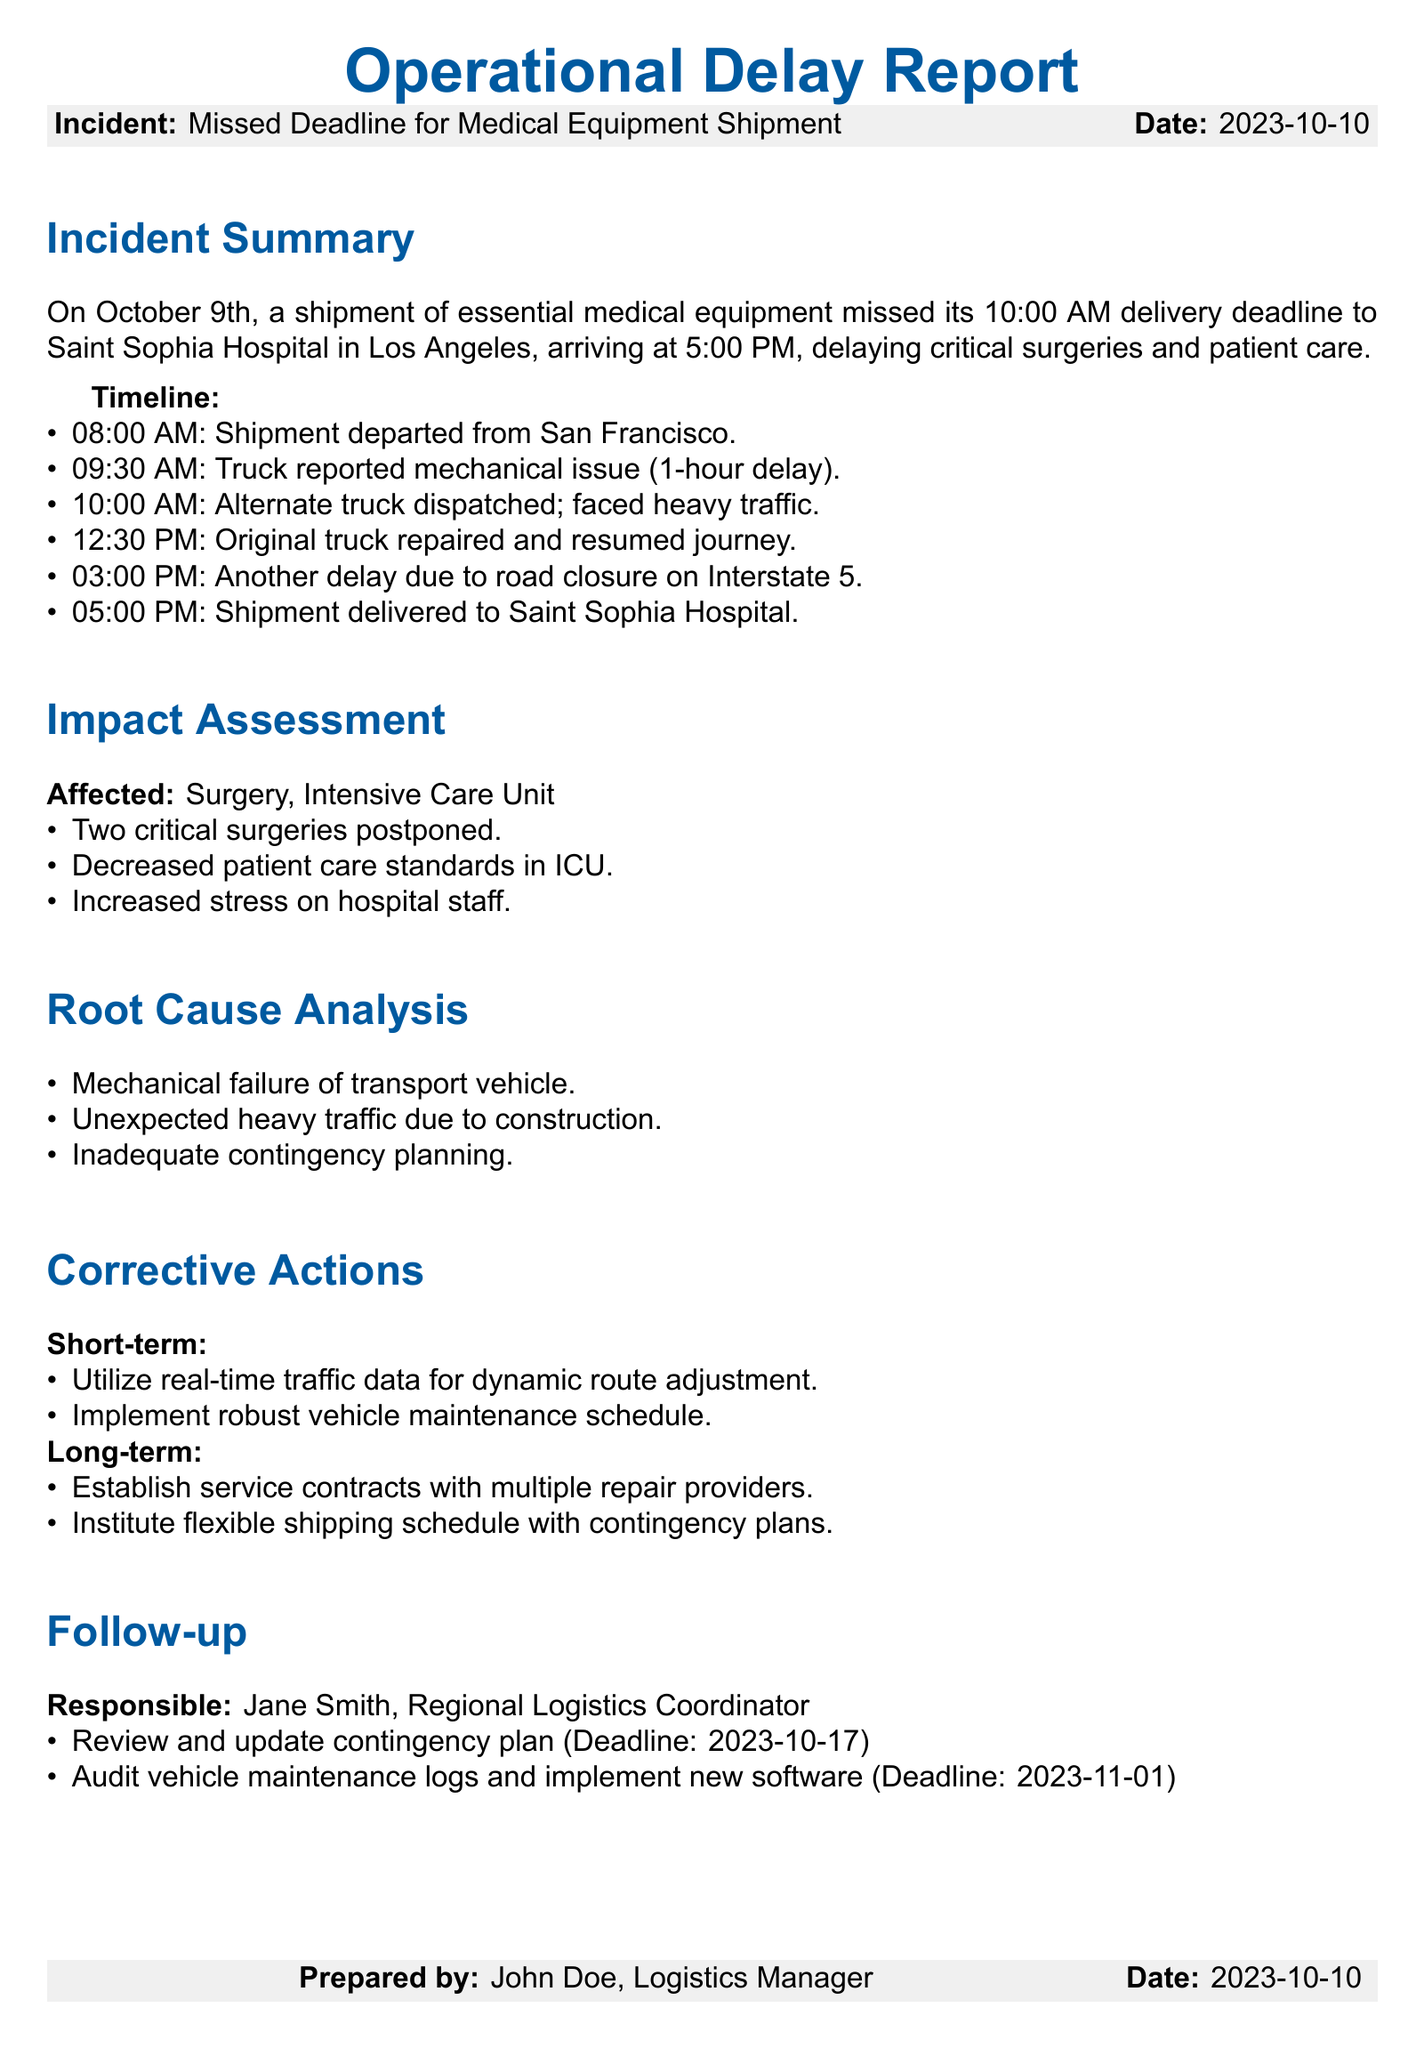What was the delivery deadline for the shipment? The delivery deadline for the shipment was set for 10:00 AM on October 9th.
Answer: 10:00 AM What time did the original truck depart? The original truck departed from San Francisco at 08:00 AM.
Answer: 08:00 AM How many critical surgeries were postponed? The report states that two critical surgeries were postponed due to the missed deadline.
Answer: Two Who is responsible for the follow-up actions? The responsible individual for the follow-up actions is Jane Smith, the Regional Logistics Coordinator.
Answer: Jane Smith What was one of the root causes of the incident? One of the root causes identified was the mechanical failure of the transport vehicle.
Answer: Mechanical failure What date is the deadline for reviewing and updating the contingency plan? The deadline for reviewing and updating the contingency plan is set for October 17, 2023.
Answer: 2023-10-17 What time was the shipment finally delivered to the hospital? The shipment was finally delivered to Saint Sophia Hospital at 05:00 PM.
Answer: 05:00 PM Which medical unit was affected by the incident? The affected medical unit mentioned in the report is the Intensive Care Unit (ICU).
Answer: Intensive Care Unit What type of traffic data should be utilized for short-term corrective actions? Real-time traffic data should be utilized for dynamic route adjustment as a short-term action.
Answer: Real-time traffic data 